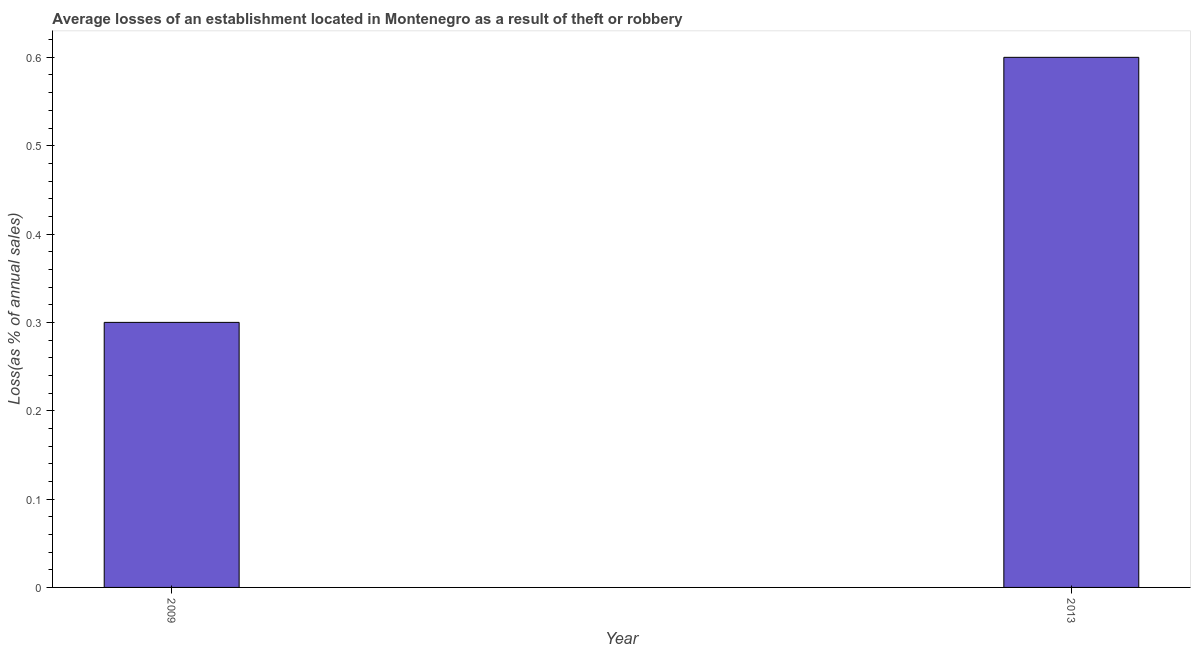Does the graph contain any zero values?
Your answer should be very brief. No. What is the title of the graph?
Give a very brief answer. Average losses of an establishment located in Montenegro as a result of theft or robbery. What is the label or title of the X-axis?
Your answer should be very brief. Year. What is the label or title of the Y-axis?
Give a very brief answer. Loss(as % of annual sales). What is the losses due to theft in 2009?
Give a very brief answer. 0.3. Across all years, what is the maximum losses due to theft?
Your answer should be very brief. 0.6. Across all years, what is the minimum losses due to theft?
Your answer should be very brief. 0.3. What is the sum of the losses due to theft?
Your answer should be compact. 0.9. What is the difference between the losses due to theft in 2009 and 2013?
Make the answer very short. -0.3. What is the average losses due to theft per year?
Keep it short and to the point. 0.45. What is the median losses due to theft?
Offer a very short reply. 0.45. Do a majority of the years between 2009 and 2013 (inclusive) have losses due to theft greater than 0.24 %?
Your answer should be very brief. Yes. Are all the bars in the graph horizontal?
Make the answer very short. No. What is the difference between two consecutive major ticks on the Y-axis?
Offer a very short reply. 0.1. Are the values on the major ticks of Y-axis written in scientific E-notation?
Give a very brief answer. No. What is the Loss(as % of annual sales) of 2013?
Keep it short and to the point. 0.6. What is the difference between the Loss(as % of annual sales) in 2009 and 2013?
Offer a very short reply. -0.3. What is the ratio of the Loss(as % of annual sales) in 2009 to that in 2013?
Offer a terse response. 0.5. 